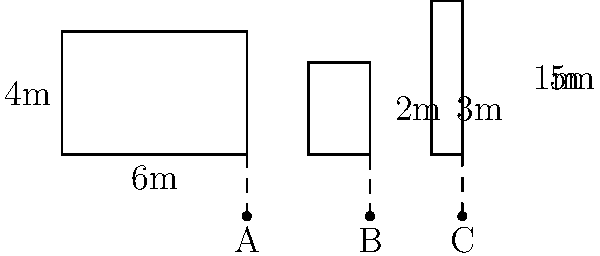Three buildings of different shapes are casting shadows at solar noon. Building 1 is a rectangular prism with a height of 4m and a width of 6m. Building 2 is a rectangular prism with a height of 3m and a width of 2m. Building 3 is a triangular prism with a base width of 1m and a height of 5m. If the shadow of Building 1 extends 2m beyond its base, what is the total length of the shadows cast by all three buildings combined? To solve this problem, we need to use the concept of similar triangles formed by the buildings and their shadows. Let's approach this step-by-step:

1) For Building 1:
   - Height (h₁) = 4m
   - Shadow length beyond base (s₁) = 2m
   - Building width (w₁) = 6m
   
   The ratio of shadow length to building height is: 2 : 4 = 1 : 2
   
   Total shadow length for Building 1: $L₁ = w₁ + s₁ = 6m + 2m = 8m$

2) For Building 2:
   - Height (h₂) = 3m
   - Building width (w₂) = 2m
   
   Using the same ratio: $\frac{s₂}{3} = \frac{1}{2}$
   $s₂ = 1.5m$
   
   Total shadow length for Building 2: $L₂ = w₂ + s₂ = 2m + 1.5m = 3.5m$

3) For Building 3:
   - Height (h₃) = 5m
   - Building width (w₃) = 1m
   
   Using the same ratio: $\frac{s₃}{5} = \frac{1}{2}$
   $s₃ = 2.5m$
   
   Total shadow length for Building 3: $L₃ = w₃ + s₃ = 1m + 2.5m = 3.5m$

4) The total length of shadows cast by all three buildings:
   $L_{total} = L₁ + L₂ + L₃ = 8m + 3.5m + 3.5m = 15m$
Answer: 15m 